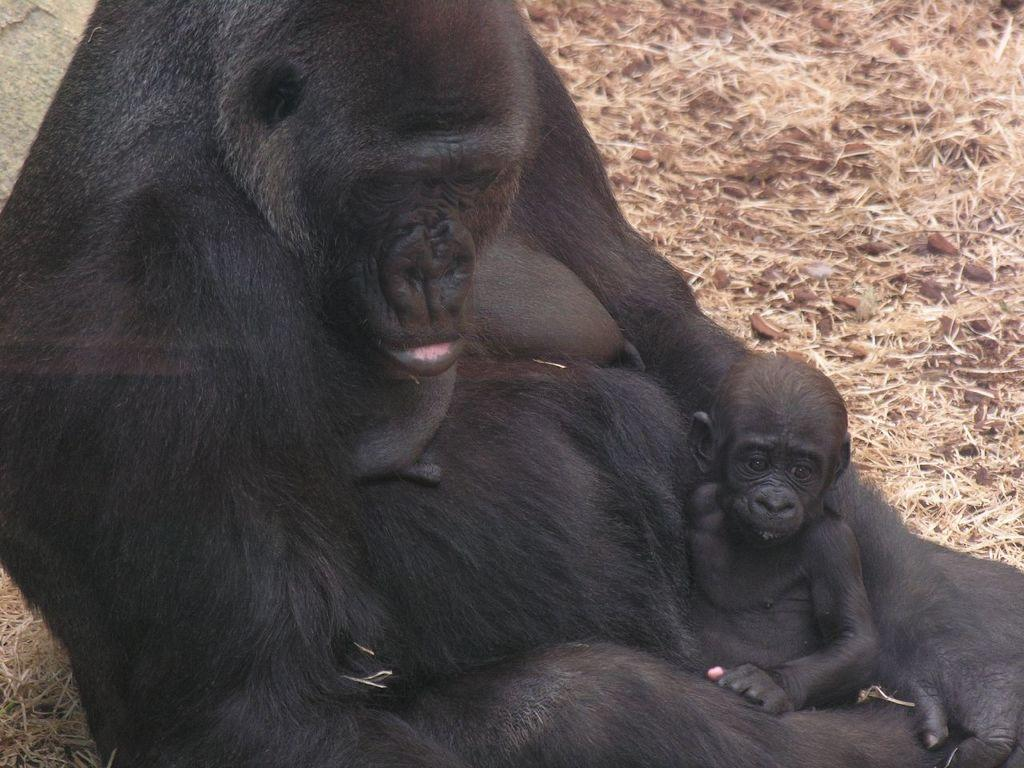What type of animal is the main subject of the image? There is a chimpanzee in the image. Can you describe any other animals present in the image? There is a baby chimpanzee in the image. What type of mark can be seen on the chimpanzee's forehead in the image? There is no mark visible on the chimpanzee's forehead in the image. What type of sound does the baby chimpanzee make in the image? The image is silent, so we cannot hear any sounds made by the baby chimpanzee. 